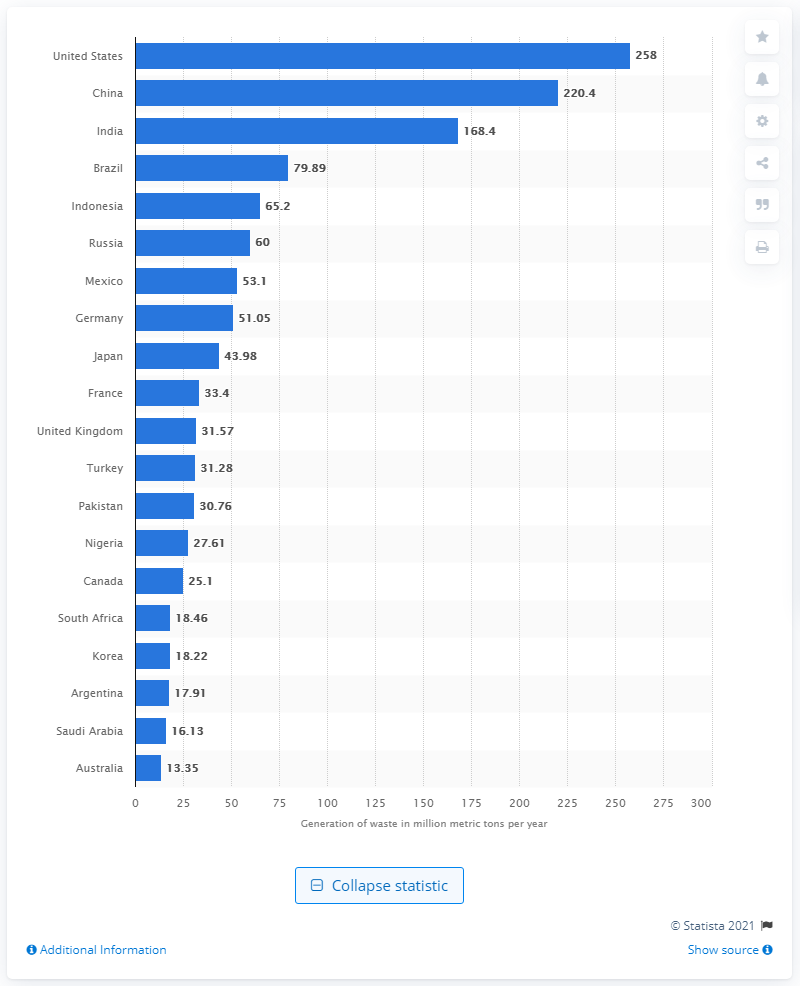Outline some significant characteristics in this image. In 2017, the United States generated 258 million metric tons of solid waste. 